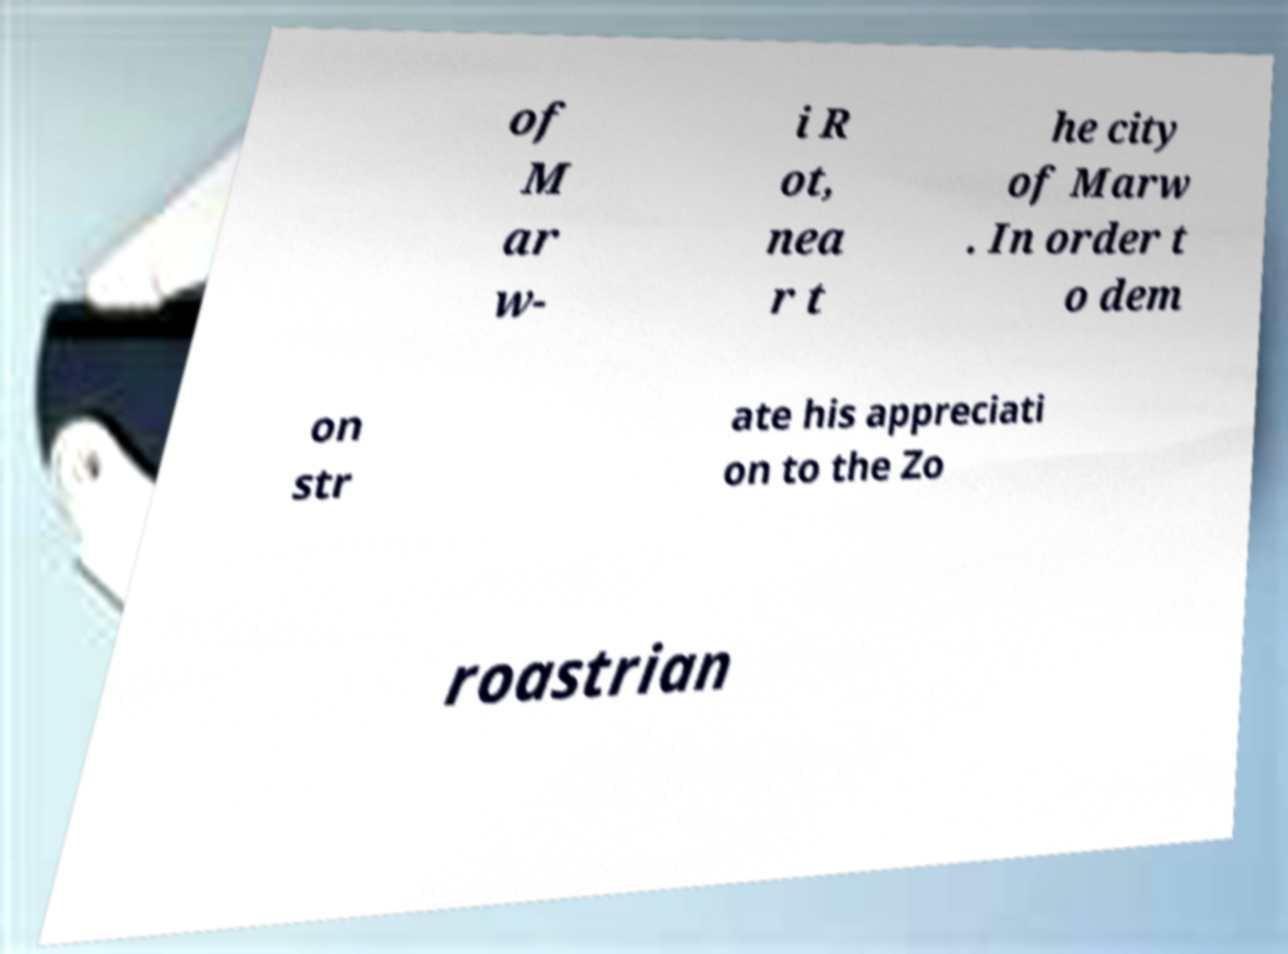Please identify and transcribe the text found in this image. of M ar w- i R ot, nea r t he city of Marw . In order t o dem on str ate his appreciati on to the Zo roastrian 